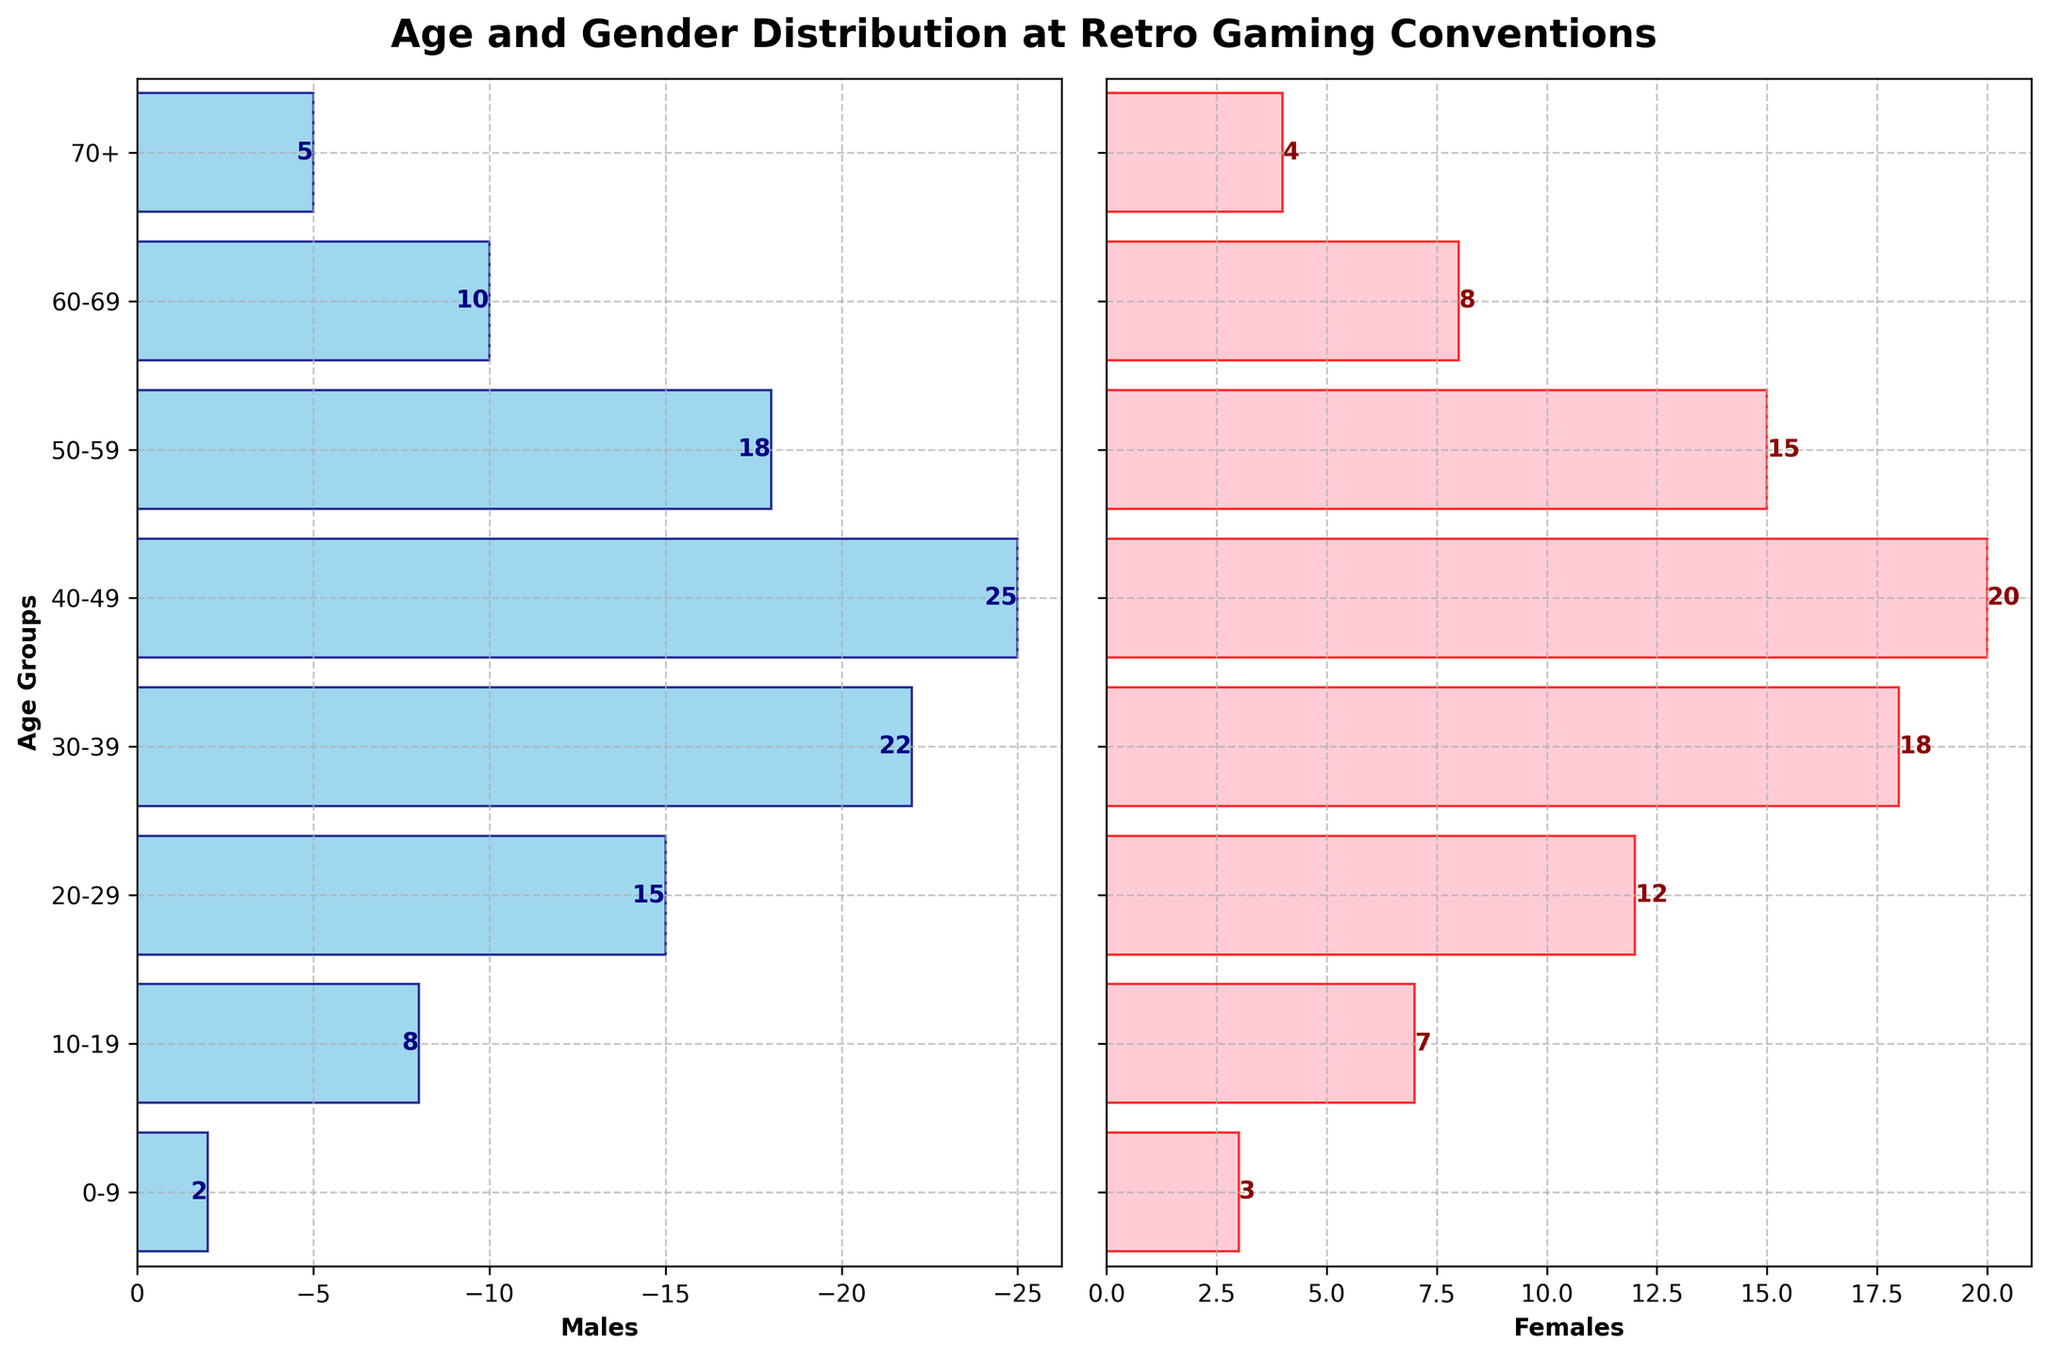What's the title of the figure? The title is located at the top center of the figure above the plot. It provides a concise description of the figure's content.
Answer: Age and Gender Distribution at Retro Gaming Conventions Which age group has the highest number of males? We examine the length of the bars for males. The longest bar corresponds to the 40-49 age group.
Answer: 40-49 How many more males than females are in the 40-49 age group? To find the answer, look at the bar lengths for 40-49. The males have 25, and the females have 20. The difference is 25 - 20.
Answer: 5 Which gender has more attendees in the 60-69 age group? Compare the bar lengths for the 60-69 age group. The male bar is longer (10) than the female bar (8).
Answer: Males What is the combined total of males and females in the 20-29 age group? Add the values of both genders in the 20-29 age group: males (15) and females (12). The total is 15 + 12.
Answer: 27 How does the number of attendees aged 0-9 compare to those aged 70+? Compare the total lengths of the bars for both genders in the 0-9 and 70+ age groups. The values are 5 (0-9) and 9 (70+).
Answer: 0-9 has fewer attendees In which age group is the gender distribution most balanced? We identify where the bars for males and females are close in length. The age group 10-19 has males (8) and females (7), a difference of only 1.
Answer: 10-19 What is the trend in the number of male attendees as the age group increases? Observe the male bars from left to right. The bars mostly increase, peaking at 40-49, and then decline.
Answer: Increase then decrease What age group has a female attendance of 15? Check for the bar labeled "15" in the females' section. It's the 50-59 age group.
Answer: 50-59 How many age groups have more than 10 female attendees? Count the bars in the females' section where the value is greater than 10. These bars are in the age groups 10-19, 20-29, 30-39, 40-49, and 50-59. There are 5 such groups.
Answer: 5 age groups 